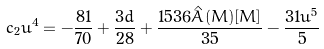<formula> <loc_0><loc_0><loc_500><loc_500>c _ { 2 } u ^ { 4 } = - \frac { 8 1 } { 7 0 } + \frac { 3 d } { 2 8 } + \frac { 1 5 3 6 \hat { A } ( M ) [ M ] } { 3 5 } - \frac { 3 1 u ^ { 5 } } { 5 }</formula> 